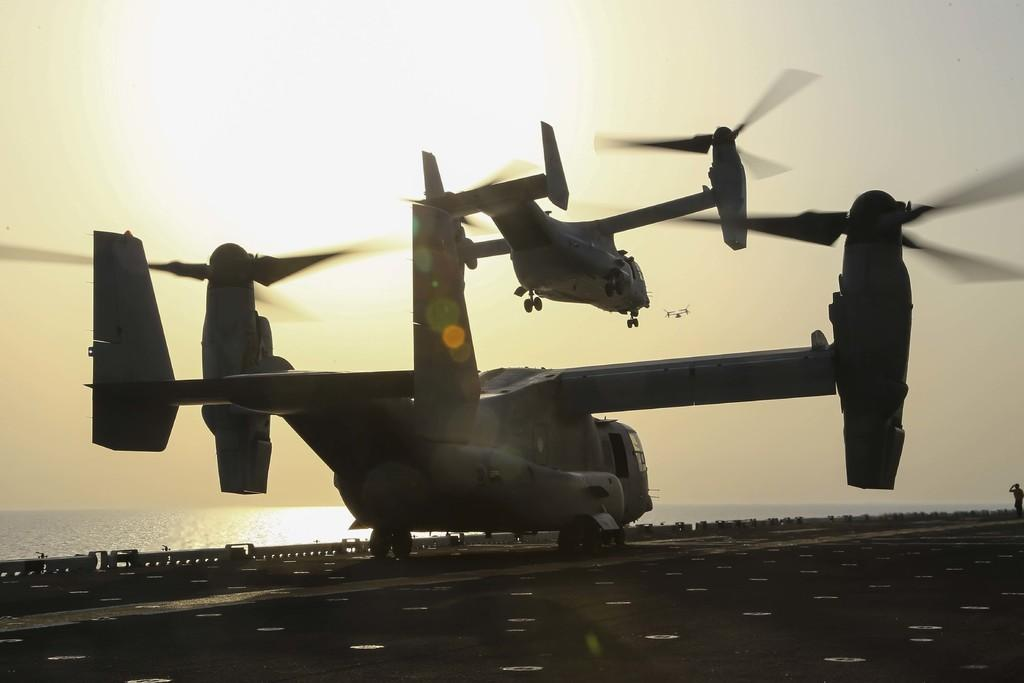What is the main subject of the image? The main subject of the image is an helicopter standing on the ground. Can you describe another helicopter in the image? Yes, there is another helicopter flying in the sky in the image. What is the condition of the sky in the image? The sky is clear in the image. How many cups of gold can be seen in the image? There are no cups or gold present in the image. What type of pigs are visible in the image? There are no pigs present in the image. 